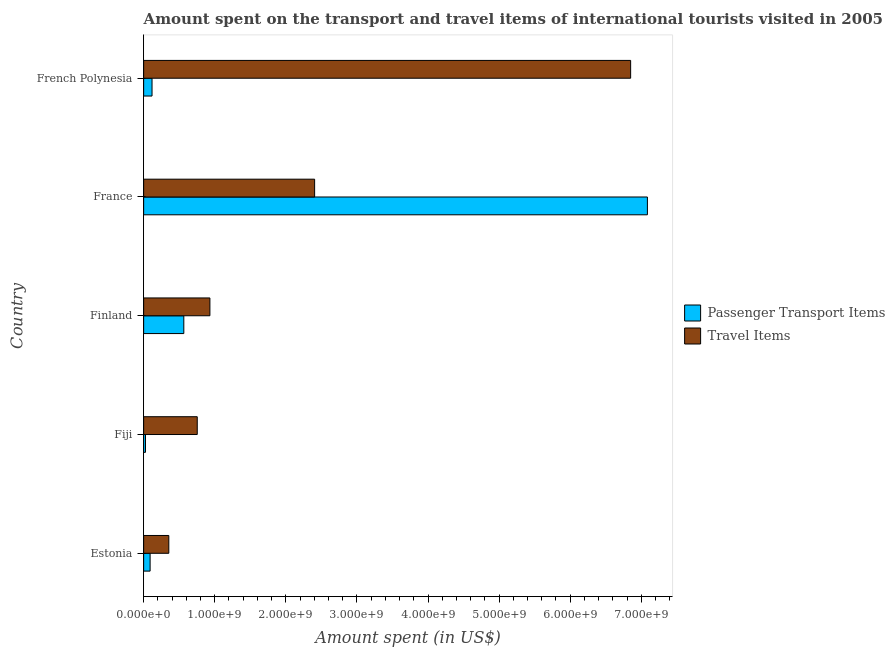How many groups of bars are there?
Give a very brief answer. 5. Are the number of bars per tick equal to the number of legend labels?
Your answer should be compact. Yes. Are the number of bars on each tick of the Y-axis equal?
Offer a terse response. Yes. How many bars are there on the 2nd tick from the top?
Make the answer very short. 2. How many bars are there on the 3rd tick from the bottom?
Keep it short and to the point. 2. What is the label of the 4th group of bars from the top?
Make the answer very short. Fiji. In how many cases, is the number of bars for a given country not equal to the number of legend labels?
Your answer should be compact. 0. What is the amount spent on passenger transport items in Estonia?
Give a very brief answer. 9.10e+07. Across all countries, what is the maximum amount spent on passenger transport items?
Provide a short and direct response. 7.09e+09. Across all countries, what is the minimum amount spent in travel items?
Provide a short and direct response. 3.54e+08. In which country was the amount spent in travel items minimum?
Provide a succinct answer. Estonia. What is the total amount spent on passenger transport items in the graph?
Your answer should be very brief. 7.89e+09. What is the difference between the amount spent on passenger transport items in Estonia and that in France?
Your answer should be very brief. -7.00e+09. What is the difference between the amount spent on passenger transport items in Fiji and the amount spent in travel items in Estonia?
Provide a short and direct response. -3.28e+08. What is the average amount spent on passenger transport items per country?
Your answer should be very brief. 1.58e+09. What is the difference between the amount spent on passenger transport items and amount spent in travel items in French Polynesia?
Provide a short and direct response. -6.73e+09. What is the ratio of the amount spent on passenger transport items in Fiji to that in France?
Offer a very short reply. 0. Is the amount spent on passenger transport items in Finland less than that in French Polynesia?
Offer a terse response. No. Is the difference between the amount spent on passenger transport items in Fiji and Finland greater than the difference between the amount spent in travel items in Fiji and Finland?
Offer a very short reply. No. What is the difference between the highest and the second highest amount spent in travel items?
Make the answer very short. 4.44e+09. What is the difference between the highest and the lowest amount spent on passenger transport items?
Offer a terse response. 7.06e+09. In how many countries, is the amount spent on passenger transport items greater than the average amount spent on passenger transport items taken over all countries?
Ensure brevity in your answer.  1. What does the 2nd bar from the top in Estonia represents?
Offer a very short reply. Passenger Transport Items. What does the 1st bar from the bottom in Estonia represents?
Ensure brevity in your answer.  Passenger Transport Items. Are all the bars in the graph horizontal?
Offer a very short reply. Yes. What is the difference between two consecutive major ticks on the X-axis?
Provide a succinct answer. 1.00e+09. Are the values on the major ticks of X-axis written in scientific E-notation?
Offer a terse response. Yes. Where does the legend appear in the graph?
Make the answer very short. Center right. How many legend labels are there?
Provide a succinct answer. 2. How are the legend labels stacked?
Offer a terse response. Vertical. What is the title of the graph?
Give a very brief answer. Amount spent on the transport and travel items of international tourists visited in 2005. Does "Total Population" appear as one of the legend labels in the graph?
Give a very brief answer. No. What is the label or title of the X-axis?
Provide a short and direct response. Amount spent (in US$). What is the Amount spent (in US$) in Passenger Transport Items in Estonia?
Your answer should be compact. 9.10e+07. What is the Amount spent (in US$) of Travel Items in Estonia?
Ensure brevity in your answer.  3.54e+08. What is the Amount spent (in US$) of Passenger Transport Items in Fiji?
Provide a succinct answer. 2.60e+07. What is the Amount spent (in US$) in Travel Items in Fiji?
Make the answer very short. 7.54e+08. What is the Amount spent (in US$) in Passenger Transport Items in Finland?
Offer a very short reply. 5.65e+08. What is the Amount spent (in US$) of Travel Items in Finland?
Offer a very short reply. 9.32e+08. What is the Amount spent (in US$) of Passenger Transport Items in France?
Provide a short and direct response. 7.09e+09. What is the Amount spent (in US$) of Travel Items in France?
Ensure brevity in your answer.  2.40e+09. What is the Amount spent (in US$) in Passenger Transport Items in French Polynesia?
Keep it short and to the point. 1.18e+08. What is the Amount spent (in US$) of Travel Items in French Polynesia?
Keep it short and to the point. 6.85e+09. Across all countries, what is the maximum Amount spent (in US$) of Passenger Transport Items?
Make the answer very short. 7.09e+09. Across all countries, what is the maximum Amount spent (in US$) in Travel Items?
Offer a terse response. 6.85e+09. Across all countries, what is the minimum Amount spent (in US$) in Passenger Transport Items?
Offer a very short reply. 2.60e+07. Across all countries, what is the minimum Amount spent (in US$) of Travel Items?
Your response must be concise. 3.54e+08. What is the total Amount spent (in US$) of Passenger Transport Items in the graph?
Your answer should be very brief. 7.89e+09. What is the total Amount spent (in US$) of Travel Items in the graph?
Offer a terse response. 1.13e+1. What is the difference between the Amount spent (in US$) of Passenger Transport Items in Estonia and that in Fiji?
Provide a succinct answer. 6.50e+07. What is the difference between the Amount spent (in US$) of Travel Items in Estonia and that in Fiji?
Provide a succinct answer. -4.00e+08. What is the difference between the Amount spent (in US$) of Passenger Transport Items in Estonia and that in Finland?
Ensure brevity in your answer.  -4.74e+08. What is the difference between the Amount spent (in US$) of Travel Items in Estonia and that in Finland?
Make the answer very short. -5.78e+08. What is the difference between the Amount spent (in US$) in Passenger Transport Items in Estonia and that in France?
Your response must be concise. -7.00e+09. What is the difference between the Amount spent (in US$) of Travel Items in Estonia and that in France?
Your answer should be compact. -2.05e+09. What is the difference between the Amount spent (in US$) of Passenger Transport Items in Estonia and that in French Polynesia?
Ensure brevity in your answer.  -2.70e+07. What is the difference between the Amount spent (in US$) of Travel Items in Estonia and that in French Polynesia?
Provide a succinct answer. -6.50e+09. What is the difference between the Amount spent (in US$) of Passenger Transport Items in Fiji and that in Finland?
Offer a very short reply. -5.39e+08. What is the difference between the Amount spent (in US$) of Travel Items in Fiji and that in Finland?
Offer a terse response. -1.78e+08. What is the difference between the Amount spent (in US$) in Passenger Transport Items in Fiji and that in France?
Your answer should be compact. -7.06e+09. What is the difference between the Amount spent (in US$) of Travel Items in Fiji and that in France?
Make the answer very short. -1.65e+09. What is the difference between the Amount spent (in US$) of Passenger Transport Items in Fiji and that in French Polynesia?
Offer a very short reply. -9.20e+07. What is the difference between the Amount spent (in US$) in Travel Items in Fiji and that in French Polynesia?
Ensure brevity in your answer.  -6.10e+09. What is the difference between the Amount spent (in US$) of Passenger Transport Items in Finland and that in France?
Your response must be concise. -6.52e+09. What is the difference between the Amount spent (in US$) of Travel Items in Finland and that in France?
Ensure brevity in your answer.  -1.47e+09. What is the difference between the Amount spent (in US$) of Passenger Transport Items in Finland and that in French Polynesia?
Offer a very short reply. 4.47e+08. What is the difference between the Amount spent (in US$) in Travel Items in Finland and that in French Polynesia?
Make the answer very short. -5.92e+09. What is the difference between the Amount spent (in US$) in Passenger Transport Items in France and that in French Polynesia?
Your answer should be compact. 6.97e+09. What is the difference between the Amount spent (in US$) of Travel Items in France and that in French Polynesia?
Give a very brief answer. -4.44e+09. What is the difference between the Amount spent (in US$) of Passenger Transport Items in Estonia and the Amount spent (in US$) of Travel Items in Fiji?
Offer a terse response. -6.63e+08. What is the difference between the Amount spent (in US$) of Passenger Transport Items in Estonia and the Amount spent (in US$) of Travel Items in Finland?
Your answer should be compact. -8.41e+08. What is the difference between the Amount spent (in US$) of Passenger Transport Items in Estonia and the Amount spent (in US$) of Travel Items in France?
Make the answer very short. -2.31e+09. What is the difference between the Amount spent (in US$) of Passenger Transport Items in Estonia and the Amount spent (in US$) of Travel Items in French Polynesia?
Ensure brevity in your answer.  -6.76e+09. What is the difference between the Amount spent (in US$) of Passenger Transport Items in Fiji and the Amount spent (in US$) of Travel Items in Finland?
Provide a succinct answer. -9.06e+08. What is the difference between the Amount spent (in US$) of Passenger Transport Items in Fiji and the Amount spent (in US$) of Travel Items in France?
Your answer should be compact. -2.38e+09. What is the difference between the Amount spent (in US$) of Passenger Transport Items in Fiji and the Amount spent (in US$) of Travel Items in French Polynesia?
Offer a very short reply. -6.82e+09. What is the difference between the Amount spent (in US$) of Passenger Transport Items in Finland and the Amount spent (in US$) of Travel Items in France?
Offer a terse response. -1.84e+09. What is the difference between the Amount spent (in US$) of Passenger Transport Items in Finland and the Amount spent (in US$) of Travel Items in French Polynesia?
Your response must be concise. -6.28e+09. What is the difference between the Amount spent (in US$) in Passenger Transport Items in France and the Amount spent (in US$) in Travel Items in French Polynesia?
Give a very brief answer. 2.36e+08. What is the average Amount spent (in US$) in Passenger Transport Items per country?
Make the answer very short. 1.58e+09. What is the average Amount spent (in US$) of Travel Items per country?
Your answer should be compact. 2.26e+09. What is the difference between the Amount spent (in US$) of Passenger Transport Items and Amount spent (in US$) of Travel Items in Estonia?
Your answer should be compact. -2.63e+08. What is the difference between the Amount spent (in US$) in Passenger Transport Items and Amount spent (in US$) in Travel Items in Fiji?
Offer a very short reply. -7.28e+08. What is the difference between the Amount spent (in US$) of Passenger Transport Items and Amount spent (in US$) of Travel Items in Finland?
Your answer should be compact. -3.67e+08. What is the difference between the Amount spent (in US$) in Passenger Transport Items and Amount spent (in US$) in Travel Items in France?
Make the answer very short. 4.68e+09. What is the difference between the Amount spent (in US$) of Passenger Transport Items and Amount spent (in US$) of Travel Items in French Polynesia?
Give a very brief answer. -6.73e+09. What is the ratio of the Amount spent (in US$) of Passenger Transport Items in Estonia to that in Fiji?
Your answer should be compact. 3.5. What is the ratio of the Amount spent (in US$) in Travel Items in Estonia to that in Fiji?
Make the answer very short. 0.47. What is the ratio of the Amount spent (in US$) in Passenger Transport Items in Estonia to that in Finland?
Your response must be concise. 0.16. What is the ratio of the Amount spent (in US$) in Travel Items in Estonia to that in Finland?
Keep it short and to the point. 0.38. What is the ratio of the Amount spent (in US$) in Passenger Transport Items in Estonia to that in France?
Ensure brevity in your answer.  0.01. What is the ratio of the Amount spent (in US$) of Travel Items in Estonia to that in France?
Keep it short and to the point. 0.15. What is the ratio of the Amount spent (in US$) in Passenger Transport Items in Estonia to that in French Polynesia?
Ensure brevity in your answer.  0.77. What is the ratio of the Amount spent (in US$) of Travel Items in Estonia to that in French Polynesia?
Your answer should be very brief. 0.05. What is the ratio of the Amount spent (in US$) of Passenger Transport Items in Fiji to that in Finland?
Your response must be concise. 0.05. What is the ratio of the Amount spent (in US$) in Travel Items in Fiji to that in Finland?
Keep it short and to the point. 0.81. What is the ratio of the Amount spent (in US$) of Passenger Transport Items in Fiji to that in France?
Your answer should be very brief. 0. What is the ratio of the Amount spent (in US$) of Travel Items in Fiji to that in France?
Give a very brief answer. 0.31. What is the ratio of the Amount spent (in US$) in Passenger Transport Items in Fiji to that in French Polynesia?
Your answer should be very brief. 0.22. What is the ratio of the Amount spent (in US$) of Travel Items in Fiji to that in French Polynesia?
Your answer should be compact. 0.11. What is the ratio of the Amount spent (in US$) in Passenger Transport Items in Finland to that in France?
Provide a succinct answer. 0.08. What is the ratio of the Amount spent (in US$) of Travel Items in Finland to that in France?
Offer a terse response. 0.39. What is the ratio of the Amount spent (in US$) in Passenger Transport Items in Finland to that in French Polynesia?
Your answer should be very brief. 4.79. What is the ratio of the Amount spent (in US$) of Travel Items in Finland to that in French Polynesia?
Ensure brevity in your answer.  0.14. What is the ratio of the Amount spent (in US$) of Passenger Transport Items in France to that in French Polynesia?
Offer a very short reply. 60.05. What is the ratio of the Amount spent (in US$) in Travel Items in France to that in French Polynesia?
Keep it short and to the point. 0.35. What is the difference between the highest and the second highest Amount spent (in US$) in Passenger Transport Items?
Provide a succinct answer. 6.52e+09. What is the difference between the highest and the second highest Amount spent (in US$) in Travel Items?
Offer a terse response. 4.44e+09. What is the difference between the highest and the lowest Amount spent (in US$) of Passenger Transport Items?
Provide a short and direct response. 7.06e+09. What is the difference between the highest and the lowest Amount spent (in US$) of Travel Items?
Ensure brevity in your answer.  6.50e+09. 